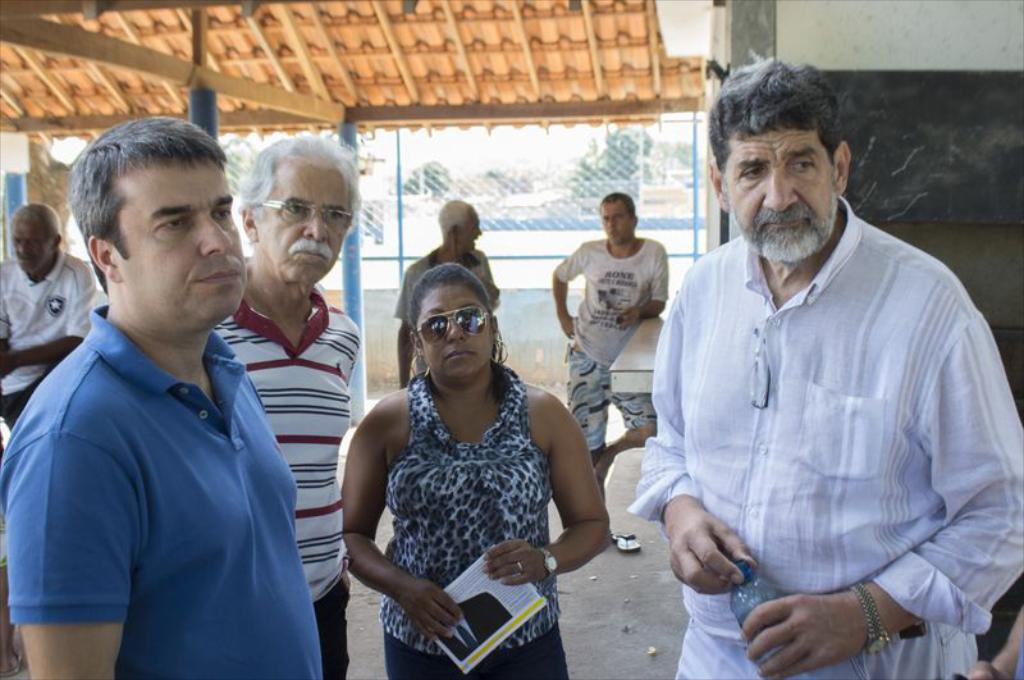What are the people in the image doing? There are groups of people standing on the path in the image. Can you describe what the woman is holding? The woman is holding a paper. What is visible behind the people? There is a wall, a fence, and trees behind the people. What type of education does the creator of the fence in the image have? There is no information about the creator of the fence in the image, nor is there any indication that the fence was created by a specific individual. 